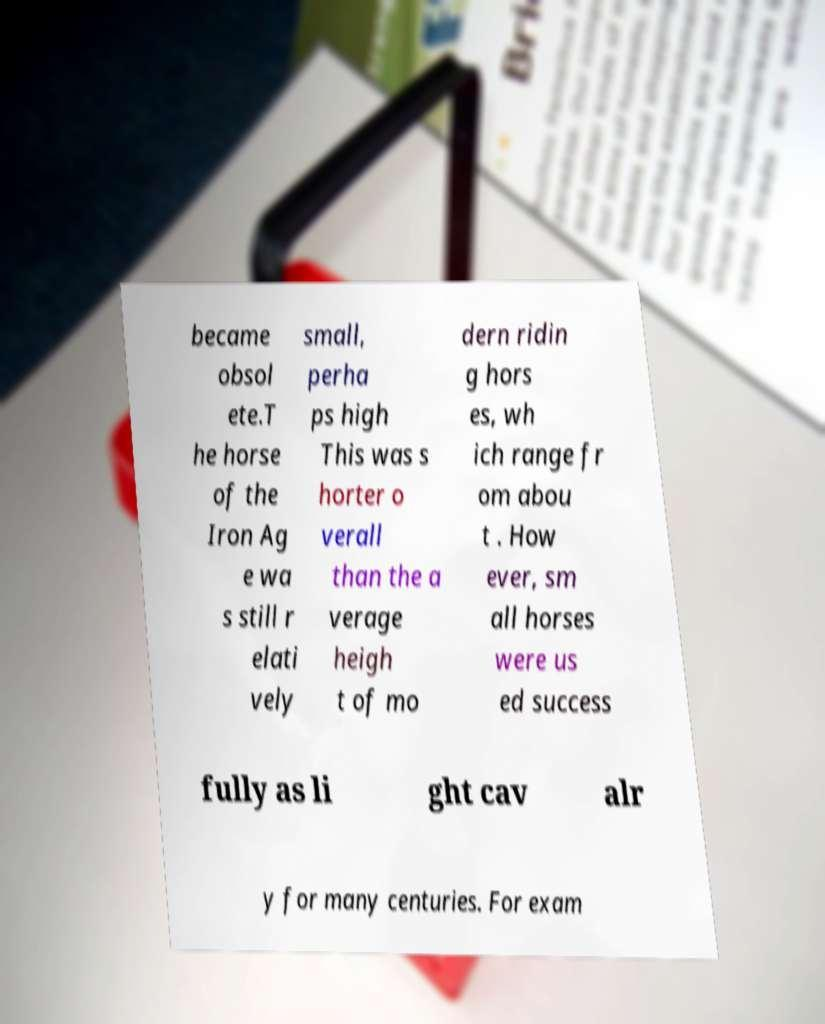Can you accurately transcribe the text from the provided image for me? became obsol ete.T he horse of the Iron Ag e wa s still r elati vely small, perha ps high This was s horter o verall than the a verage heigh t of mo dern ridin g hors es, wh ich range fr om abou t . How ever, sm all horses were us ed success fully as li ght cav alr y for many centuries. For exam 